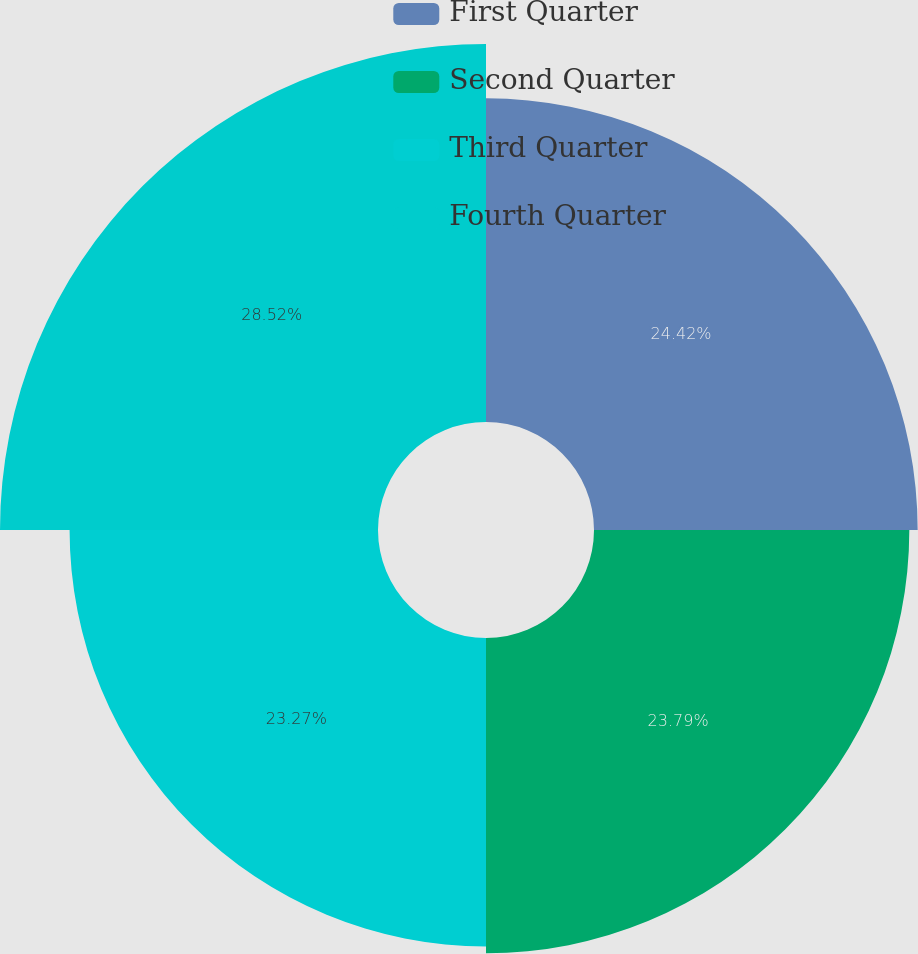<chart> <loc_0><loc_0><loc_500><loc_500><pie_chart><fcel>First Quarter<fcel>Second Quarter<fcel>Third Quarter<fcel>Fourth Quarter<nl><fcel>24.42%<fcel>23.79%<fcel>23.27%<fcel>28.52%<nl></chart> 